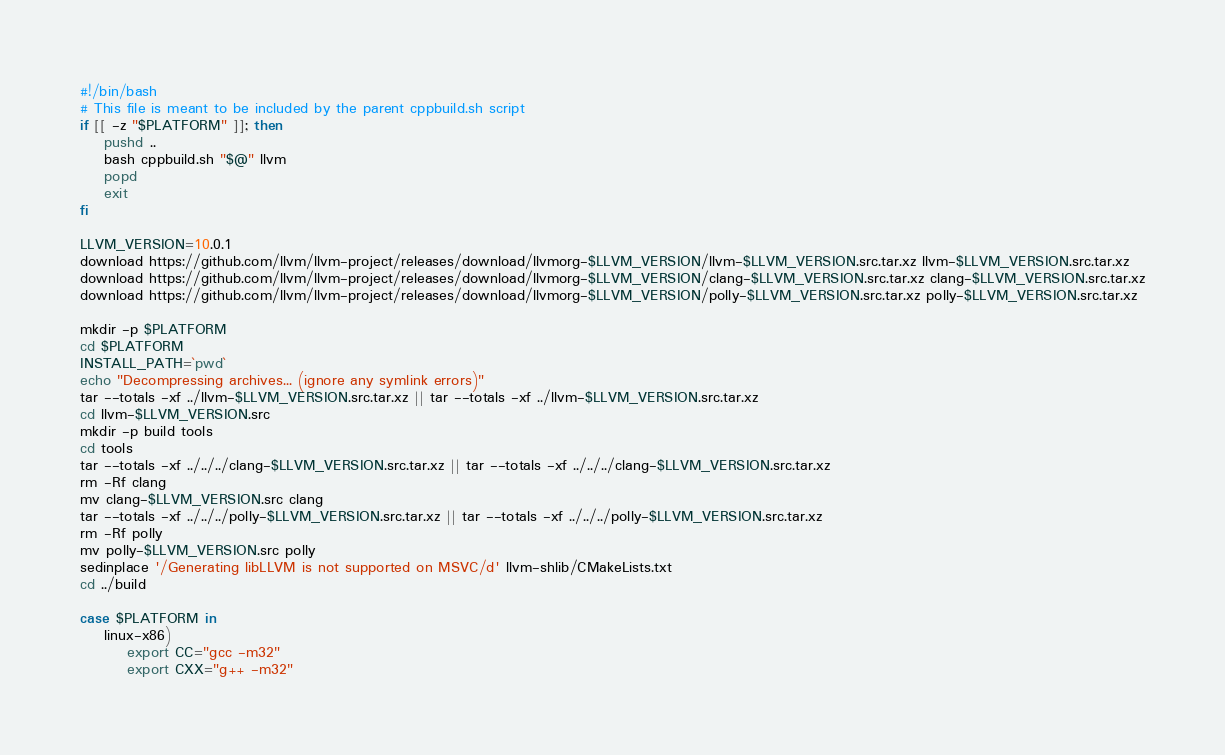Convert code to text. <code><loc_0><loc_0><loc_500><loc_500><_Bash_>#!/bin/bash
# This file is meant to be included by the parent cppbuild.sh script
if [[ -z "$PLATFORM" ]]; then
    pushd ..
    bash cppbuild.sh "$@" llvm
    popd
    exit
fi

LLVM_VERSION=10.0.1
download https://github.com/llvm/llvm-project/releases/download/llvmorg-$LLVM_VERSION/llvm-$LLVM_VERSION.src.tar.xz llvm-$LLVM_VERSION.src.tar.xz
download https://github.com/llvm/llvm-project/releases/download/llvmorg-$LLVM_VERSION/clang-$LLVM_VERSION.src.tar.xz clang-$LLVM_VERSION.src.tar.xz
download https://github.com/llvm/llvm-project/releases/download/llvmorg-$LLVM_VERSION/polly-$LLVM_VERSION.src.tar.xz polly-$LLVM_VERSION.src.tar.xz

mkdir -p $PLATFORM
cd $PLATFORM
INSTALL_PATH=`pwd`
echo "Decompressing archives... (ignore any symlink errors)"
tar --totals -xf ../llvm-$LLVM_VERSION.src.tar.xz || tar --totals -xf ../llvm-$LLVM_VERSION.src.tar.xz
cd llvm-$LLVM_VERSION.src
mkdir -p build tools
cd tools
tar --totals -xf ../../../clang-$LLVM_VERSION.src.tar.xz || tar --totals -xf ../../../clang-$LLVM_VERSION.src.tar.xz
rm -Rf clang
mv clang-$LLVM_VERSION.src clang
tar --totals -xf ../../../polly-$LLVM_VERSION.src.tar.xz || tar --totals -xf ../../../polly-$LLVM_VERSION.src.tar.xz
rm -Rf polly
mv polly-$LLVM_VERSION.src polly
sedinplace '/Generating libLLVM is not supported on MSVC/d' llvm-shlib/CMakeLists.txt
cd ../build

case $PLATFORM in
    linux-x86)
        export CC="gcc -m32"
        export CXX="g++ -m32"</code> 